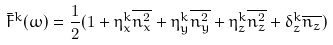Convert formula to latex. <formula><loc_0><loc_0><loc_500><loc_500>\bar { F } ^ { k } ( \omega ) = \frac { 1 } { 2 } ( 1 + \eta ^ { k } _ { x } \overline { n _ { x } ^ { 2 } } + \eta ^ { k } _ { y } \overline { n _ { y } ^ { 2 } } + \eta ^ { k } _ { z } \overline { n _ { z } ^ { 2 } } + \delta ^ { k } _ { z } \overline { n _ { z } } )</formula> 